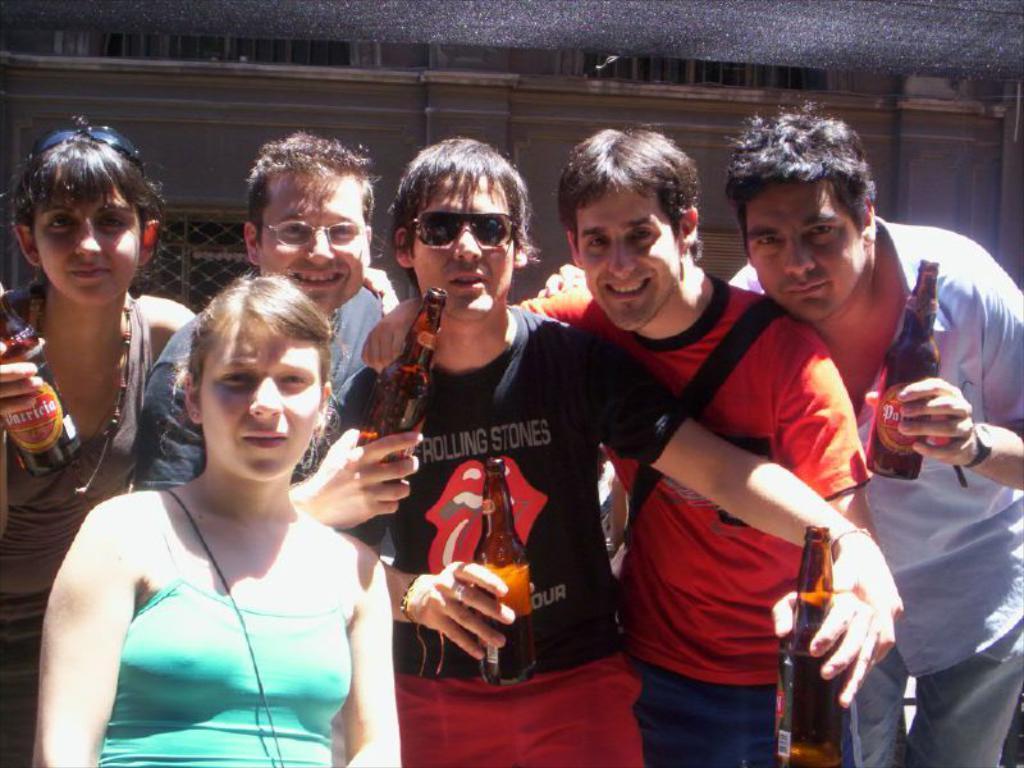In one or two sentences, can you explain what this image depicts? In this picture we can see a group of people where some are holding bottles in their hands and in background we can see wall. 